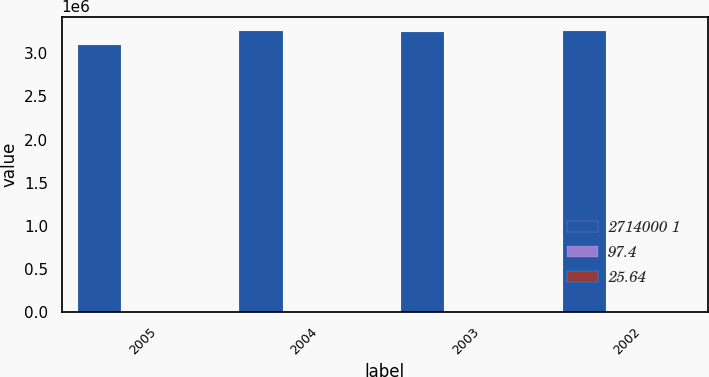Convert chart. <chart><loc_0><loc_0><loc_500><loc_500><stacked_bar_chart><ecel><fcel>2005<fcel>2004<fcel>2003<fcel>2002<nl><fcel>2714000 1<fcel>3.1e+06<fcel>3.261e+06<fcel>3.249e+06<fcel>3.262e+06<nl><fcel>97.4<fcel>97<fcel>96.5<fcel>93.6<fcel>92.8<nl><fcel>25.64<fcel>26.42<fcel>27.59<fcel>27.73<fcel>26.32<nl></chart> 